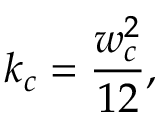Convert formula to latex. <formula><loc_0><loc_0><loc_500><loc_500>k _ { c } = \frac { w _ { c } ^ { 2 } } { 1 2 } ,</formula> 